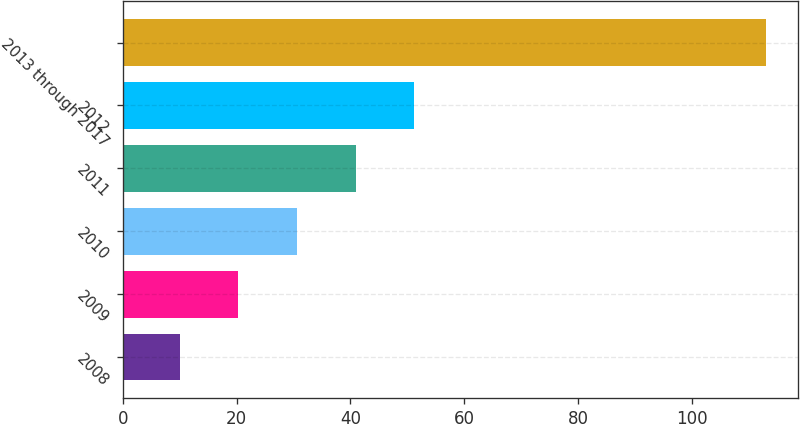<chart> <loc_0><loc_0><loc_500><loc_500><bar_chart><fcel>2008<fcel>2009<fcel>2010<fcel>2011<fcel>2012<fcel>2013 through 2017<nl><fcel>10<fcel>20.3<fcel>30.6<fcel>40.9<fcel>51.2<fcel>113<nl></chart> 